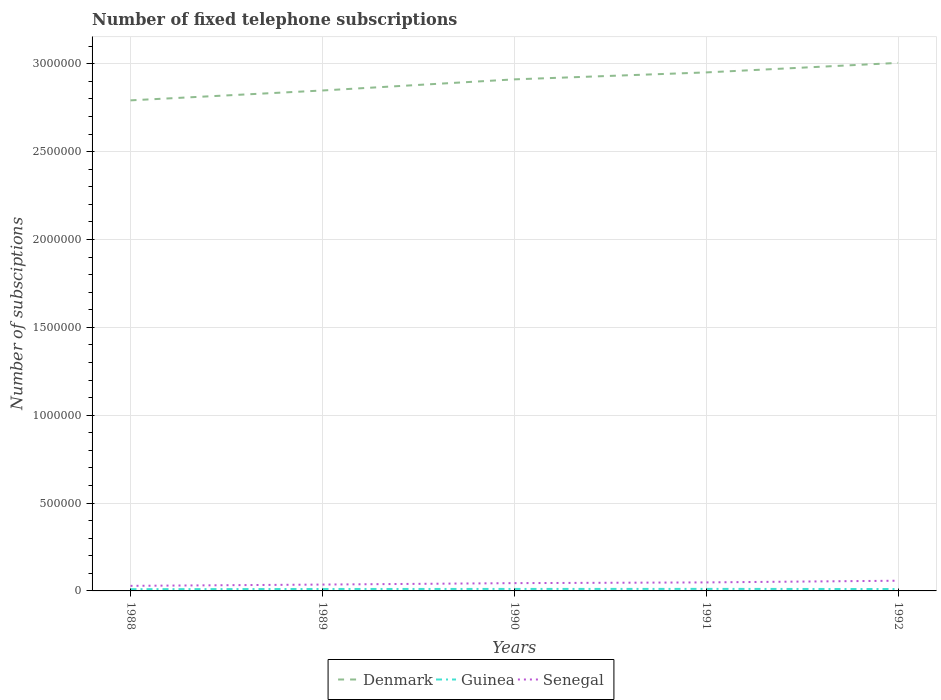What is the total number of fixed telephone subscriptions in Guinea in the graph?
Your answer should be compact. -788. What is the difference between the highest and the second highest number of fixed telephone subscriptions in Senegal?
Keep it short and to the point. 2.92e+04. What is the difference between the highest and the lowest number of fixed telephone subscriptions in Denmark?
Your response must be concise. 3. Is the number of fixed telephone subscriptions in Guinea strictly greater than the number of fixed telephone subscriptions in Senegal over the years?
Keep it short and to the point. Yes. How many years are there in the graph?
Keep it short and to the point. 5. What is the difference between two consecutive major ticks on the Y-axis?
Provide a succinct answer. 5.00e+05. Are the values on the major ticks of Y-axis written in scientific E-notation?
Keep it short and to the point. No. Does the graph contain any zero values?
Give a very brief answer. No. Does the graph contain grids?
Keep it short and to the point. Yes. Where does the legend appear in the graph?
Keep it short and to the point. Bottom center. How many legend labels are there?
Provide a succinct answer. 3. How are the legend labels stacked?
Your answer should be very brief. Horizontal. What is the title of the graph?
Ensure brevity in your answer.  Number of fixed telephone subscriptions. Does "Ghana" appear as one of the legend labels in the graph?
Provide a short and direct response. No. What is the label or title of the Y-axis?
Your response must be concise. Number of subsciptions. What is the Number of subsciptions in Denmark in 1988?
Provide a succinct answer. 2.79e+06. What is the Number of subsciptions in Guinea in 1988?
Your answer should be very brief. 10000. What is the Number of subsciptions in Senegal in 1988?
Ensure brevity in your answer.  2.89e+04. What is the Number of subsciptions of Denmark in 1989?
Your answer should be compact. 2.85e+06. What is the Number of subsciptions in Guinea in 1989?
Ensure brevity in your answer.  1.11e+04. What is the Number of subsciptions of Senegal in 1989?
Ensure brevity in your answer.  3.62e+04. What is the Number of subsciptions in Denmark in 1990?
Offer a terse response. 2.91e+06. What is the Number of subsciptions of Guinea in 1990?
Keep it short and to the point. 1.13e+04. What is the Number of subsciptions of Senegal in 1990?
Give a very brief answer. 4.43e+04. What is the Number of subsciptions in Denmark in 1991?
Keep it short and to the point. 2.95e+06. What is the Number of subsciptions of Guinea in 1991?
Ensure brevity in your answer.  1.16e+04. What is the Number of subsciptions in Senegal in 1991?
Your response must be concise. 4.85e+04. What is the Number of subsciptions in Denmark in 1992?
Offer a very short reply. 3.00e+06. What is the Number of subsciptions of Guinea in 1992?
Make the answer very short. 1.08e+04. What is the Number of subsciptions of Senegal in 1992?
Make the answer very short. 5.81e+04. Across all years, what is the maximum Number of subsciptions in Denmark?
Give a very brief answer. 3.00e+06. Across all years, what is the maximum Number of subsciptions in Guinea?
Make the answer very short. 1.16e+04. Across all years, what is the maximum Number of subsciptions of Senegal?
Offer a very short reply. 5.81e+04. Across all years, what is the minimum Number of subsciptions of Denmark?
Offer a terse response. 2.79e+06. Across all years, what is the minimum Number of subsciptions of Guinea?
Ensure brevity in your answer.  10000. Across all years, what is the minimum Number of subsciptions in Senegal?
Your answer should be very brief. 2.89e+04. What is the total Number of subsciptions of Denmark in the graph?
Offer a very short reply. 1.45e+07. What is the total Number of subsciptions in Guinea in the graph?
Ensure brevity in your answer.  5.47e+04. What is the total Number of subsciptions in Senegal in the graph?
Offer a terse response. 2.16e+05. What is the difference between the Number of subsciptions of Denmark in 1988 and that in 1989?
Make the answer very short. -5.61e+04. What is the difference between the Number of subsciptions in Guinea in 1988 and that in 1989?
Give a very brief answer. -1053. What is the difference between the Number of subsciptions in Senegal in 1988 and that in 1989?
Offer a very short reply. -7233. What is the difference between the Number of subsciptions of Denmark in 1988 and that in 1990?
Provide a short and direct response. -1.19e+05. What is the difference between the Number of subsciptions of Guinea in 1988 and that in 1990?
Your response must be concise. -1300. What is the difference between the Number of subsciptions of Senegal in 1988 and that in 1990?
Your answer should be very brief. -1.54e+04. What is the difference between the Number of subsciptions of Denmark in 1988 and that in 1991?
Provide a succinct answer. -1.59e+05. What is the difference between the Number of subsciptions of Guinea in 1988 and that in 1991?
Offer a very short reply. -1553. What is the difference between the Number of subsciptions of Senegal in 1988 and that in 1991?
Offer a very short reply. -1.95e+04. What is the difference between the Number of subsciptions of Denmark in 1988 and that in 1992?
Keep it short and to the point. -2.13e+05. What is the difference between the Number of subsciptions in Guinea in 1988 and that in 1992?
Your answer should be compact. -788. What is the difference between the Number of subsciptions in Senegal in 1988 and that in 1992?
Ensure brevity in your answer.  -2.92e+04. What is the difference between the Number of subsciptions in Denmark in 1989 and that in 1990?
Your answer should be compact. -6.33e+04. What is the difference between the Number of subsciptions of Guinea in 1989 and that in 1990?
Your answer should be compact. -247. What is the difference between the Number of subsciptions in Senegal in 1989 and that in 1990?
Offer a terse response. -8160. What is the difference between the Number of subsciptions in Denmark in 1989 and that in 1991?
Give a very brief answer. -1.03e+05. What is the difference between the Number of subsciptions in Guinea in 1989 and that in 1991?
Make the answer very short. -500. What is the difference between the Number of subsciptions of Senegal in 1989 and that in 1991?
Provide a short and direct response. -1.23e+04. What is the difference between the Number of subsciptions in Denmark in 1989 and that in 1992?
Your response must be concise. -1.57e+05. What is the difference between the Number of subsciptions of Guinea in 1989 and that in 1992?
Provide a short and direct response. 265. What is the difference between the Number of subsciptions of Senegal in 1989 and that in 1992?
Give a very brief answer. -2.19e+04. What is the difference between the Number of subsciptions in Denmark in 1990 and that in 1991?
Your response must be concise. -3.96e+04. What is the difference between the Number of subsciptions of Guinea in 1990 and that in 1991?
Ensure brevity in your answer.  -253. What is the difference between the Number of subsciptions of Senegal in 1990 and that in 1991?
Ensure brevity in your answer.  -4143. What is the difference between the Number of subsciptions in Denmark in 1990 and that in 1992?
Keep it short and to the point. -9.37e+04. What is the difference between the Number of subsciptions in Guinea in 1990 and that in 1992?
Give a very brief answer. 512. What is the difference between the Number of subsciptions of Senegal in 1990 and that in 1992?
Offer a terse response. -1.38e+04. What is the difference between the Number of subsciptions in Denmark in 1991 and that in 1992?
Ensure brevity in your answer.  -5.42e+04. What is the difference between the Number of subsciptions in Guinea in 1991 and that in 1992?
Keep it short and to the point. 765. What is the difference between the Number of subsciptions of Senegal in 1991 and that in 1992?
Provide a short and direct response. -9626. What is the difference between the Number of subsciptions of Denmark in 1988 and the Number of subsciptions of Guinea in 1989?
Provide a succinct answer. 2.78e+06. What is the difference between the Number of subsciptions of Denmark in 1988 and the Number of subsciptions of Senegal in 1989?
Provide a short and direct response. 2.76e+06. What is the difference between the Number of subsciptions in Guinea in 1988 and the Number of subsciptions in Senegal in 1989?
Provide a succinct answer. -2.62e+04. What is the difference between the Number of subsciptions in Denmark in 1988 and the Number of subsciptions in Guinea in 1990?
Offer a terse response. 2.78e+06. What is the difference between the Number of subsciptions in Denmark in 1988 and the Number of subsciptions in Senegal in 1990?
Your answer should be very brief. 2.75e+06. What is the difference between the Number of subsciptions of Guinea in 1988 and the Number of subsciptions of Senegal in 1990?
Keep it short and to the point. -3.43e+04. What is the difference between the Number of subsciptions of Denmark in 1988 and the Number of subsciptions of Guinea in 1991?
Your answer should be very brief. 2.78e+06. What is the difference between the Number of subsciptions of Denmark in 1988 and the Number of subsciptions of Senegal in 1991?
Ensure brevity in your answer.  2.74e+06. What is the difference between the Number of subsciptions of Guinea in 1988 and the Number of subsciptions of Senegal in 1991?
Make the answer very short. -3.85e+04. What is the difference between the Number of subsciptions of Denmark in 1988 and the Number of subsciptions of Guinea in 1992?
Give a very brief answer. 2.78e+06. What is the difference between the Number of subsciptions of Denmark in 1988 and the Number of subsciptions of Senegal in 1992?
Provide a short and direct response. 2.73e+06. What is the difference between the Number of subsciptions of Guinea in 1988 and the Number of subsciptions of Senegal in 1992?
Make the answer very short. -4.81e+04. What is the difference between the Number of subsciptions of Denmark in 1989 and the Number of subsciptions of Guinea in 1990?
Make the answer very short. 2.84e+06. What is the difference between the Number of subsciptions in Denmark in 1989 and the Number of subsciptions in Senegal in 1990?
Keep it short and to the point. 2.80e+06. What is the difference between the Number of subsciptions in Guinea in 1989 and the Number of subsciptions in Senegal in 1990?
Keep it short and to the point. -3.33e+04. What is the difference between the Number of subsciptions of Denmark in 1989 and the Number of subsciptions of Guinea in 1991?
Your answer should be very brief. 2.84e+06. What is the difference between the Number of subsciptions in Denmark in 1989 and the Number of subsciptions in Senegal in 1991?
Your answer should be compact. 2.80e+06. What is the difference between the Number of subsciptions in Guinea in 1989 and the Number of subsciptions in Senegal in 1991?
Give a very brief answer. -3.74e+04. What is the difference between the Number of subsciptions in Denmark in 1989 and the Number of subsciptions in Guinea in 1992?
Make the answer very short. 2.84e+06. What is the difference between the Number of subsciptions of Denmark in 1989 and the Number of subsciptions of Senegal in 1992?
Give a very brief answer. 2.79e+06. What is the difference between the Number of subsciptions in Guinea in 1989 and the Number of subsciptions in Senegal in 1992?
Offer a very short reply. -4.70e+04. What is the difference between the Number of subsciptions of Denmark in 1990 and the Number of subsciptions of Guinea in 1991?
Offer a very short reply. 2.90e+06. What is the difference between the Number of subsciptions in Denmark in 1990 and the Number of subsciptions in Senegal in 1991?
Offer a terse response. 2.86e+06. What is the difference between the Number of subsciptions in Guinea in 1990 and the Number of subsciptions in Senegal in 1991?
Provide a short and direct response. -3.72e+04. What is the difference between the Number of subsciptions in Denmark in 1990 and the Number of subsciptions in Guinea in 1992?
Give a very brief answer. 2.90e+06. What is the difference between the Number of subsciptions in Denmark in 1990 and the Number of subsciptions in Senegal in 1992?
Keep it short and to the point. 2.85e+06. What is the difference between the Number of subsciptions of Guinea in 1990 and the Number of subsciptions of Senegal in 1992?
Make the answer very short. -4.68e+04. What is the difference between the Number of subsciptions of Denmark in 1991 and the Number of subsciptions of Guinea in 1992?
Your answer should be compact. 2.94e+06. What is the difference between the Number of subsciptions of Denmark in 1991 and the Number of subsciptions of Senegal in 1992?
Make the answer very short. 2.89e+06. What is the difference between the Number of subsciptions in Guinea in 1991 and the Number of subsciptions in Senegal in 1992?
Give a very brief answer. -4.65e+04. What is the average Number of subsciptions of Denmark per year?
Keep it short and to the point. 2.90e+06. What is the average Number of subsciptions of Guinea per year?
Provide a succinct answer. 1.09e+04. What is the average Number of subsciptions in Senegal per year?
Your answer should be very brief. 4.32e+04. In the year 1988, what is the difference between the Number of subsciptions of Denmark and Number of subsciptions of Guinea?
Keep it short and to the point. 2.78e+06. In the year 1988, what is the difference between the Number of subsciptions of Denmark and Number of subsciptions of Senegal?
Offer a very short reply. 2.76e+06. In the year 1988, what is the difference between the Number of subsciptions of Guinea and Number of subsciptions of Senegal?
Provide a succinct answer. -1.89e+04. In the year 1989, what is the difference between the Number of subsciptions of Denmark and Number of subsciptions of Guinea?
Offer a very short reply. 2.84e+06. In the year 1989, what is the difference between the Number of subsciptions of Denmark and Number of subsciptions of Senegal?
Make the answer very short. 2.81e+06. In the year 1989, what is the difference between the Number of subsciptions in Guinea and Number of subsciptions in Senegal?
Offer a very short reply. -2.51e+04. In the year 1990, what is the difference between the Number of subsciptions in Denmark and Number of subsciptions in Guinea?
Offer a very short reply. 2.90e+06. In the year 1990, what is the difference between the Number of subsciptions in Denmark and Number of subsciptions in Senegal?
Provide a succinct answer. 2.87e+06. In the year 1990, what is the difference between the Number of subsciptions in Guinea and Number of subsciptions in Senegal?
Your response must be concise. -3.30e+04. In the year 1991, what is the difference between the Number of subsciptions of Denmark and Number of subsciptions of Guinea?
Ensure brevity in your answer.  2.94e+06. In the year 1991, what is the difference between the Number of subsciptions of Denmark and Number of subsciptions of Senegal?
Your answer should be very brief. 2.90e+06. In the year 1991, what is the difference between the Number of subsciptions of Guinea and Number of subsciptions of Senegal?
Ensure brevity in your answer.  -3.69e+04. In the year 1992, what is the difference between the Number of subsciptions in Denmark and Number of subsciptions in Guinea?
Make the answer very short. 2.99e+06. In the year 1992, what is the difference between the Number of subsciptions of Denmark and Number of subsciptions of Senegal?
Your answer should be very brief. 2.95e+06. In the year 1992, what is the difference between the Number of subsciptions of Guinea and Number of subsciptions of Senegal?
Ensure brevity in your answer.  -4.73e+04. What is the ratio of the Number of subsciptions of Denmark in 1988 to that in 1989?
Ensure brevity in your answer.  0.98. What is the ratio of the Number of subsciptions of Guinea in 1988 to that in 1989?
Keep it short and to the point. 0.9. What is the ratio of the Number of subsciptions in Senegal in 1988 to that in 1989?
Provide a succinct answer. 0.8. What is the ratio of the Number of subsciptions in Guinea in 1988 to that in 1990?
Ensure brevity in your answer.  0.89. What is the ratio of the Number of subsciptions of Senegal in 1988 to that in 1990?
Make the answer very short. 0.65. What is the ratio of the Number of subsciptions of Denmark in 1988 to that in 1991?
Offer a terse response. 0.95. What is the ratio of the Number of subsciptions of Guinea in 1988 to that in 1991?
Offer a very short reply. 0.87. What is the ratio of the Number of subsciptions in Senegal in 1988 to that in 1991?
Make the answer very short. 0.6. What is the ratio of the Number of subsciptions in Denmark in 1988 to that in 1992?
Your response must be concise. 0.93. What is the ratio of the Number of subsciptions in Guinea in 1988 to that in 1992?
Offer a terse response. 0.93. What is the ratio of the Number of subsciptions in Senegal in 1988 to that in 1992?
Provide a short and direct response. 0.5. What is the ratio of the Number of subsciptions in Denmark in 1989 to that in 1990?
Provide a succinct answer. 0.98. What is the ratio of the Number of subsciptions of Guinea in 1989 to that in 1990?
Provide a short and direct response. 0.98. What is the ratio of the Number of subsciptions in Senegal in 1989 to that in 1990?
Your response must be concise. 0.82. What is the ratio of the Number of subsciptions of Denmark in 1989 to that in 1991?
Make the answer very short. 0.97. What is the ratio of the Number of subsciptions in Guinea in 1989 to that in 1991?
Offer a very short reply. 0.96. What is the ratio of the Number of subsciptions in Senegal in 1989 to that in 1991?
Your response must be concise. 0.75. What is the ratio of the Number of subsciptions of Denmark in 1989 to that in 1992?
Your response must be concise. 0.95. What is the ratio of the Number of subsciptions of Guinea in 1989 to that in 1992?
Offer a terse response. 1.02. What is the ratio of the Number of subsciptions of Senegal in 1989 to that in 1992?
Provide a succinct answer. 0.62. What is the ratio of the Number of subsciptions in Denmark in 1990 to that in 1991?
Make the answer very short. 0.99. What is the ratio of the Number of subsciptions of Guinea in 1990 to that in 1991?
Give a very brief answer. 0.98. What is the ratio of the Number of subsciptions in Senegal in 1990 to that in 1991?
Provide a short and direct response. 0.91. What is the ratio of the Number of subsciptions in Denmark in 1990 to that in 1992?
Ensure brevity in your answer.  0.97. What is the ratio of the Number of subsciptions of Guinea in 1990 to that in 1992?
Your answer should be compact. 1.05. What is the ratio of the Number of subsciptions of Senegal in 1990 to that in 1992?
Make the answer very short. 0.76. What is the ratio of the Number of subsciptions in Denmark in 1991 to that in 1992?
Your answer should be compact. 0.98. What is the ratio of the Number of subsciptions of Guinea in 1991 to that in 1992?
Your response must be concise. 1.07. What is the ratio of the Number of subsciptions in Senegal in 1991 to that in 1992?
Offer a terse response. 0.83. What is the difference between the highest and the second highest Number of subsciptions of Denmark?
Keep it short and to the point. 5.42e+04. What is the difference between the highest and the second highest Number of subsciptions in Guinea?
Ensure brevity in your answer.  253. What is the difference between the highest and the second highest Number of subsciptions of Senegal?
Your answer should be compact. 9626. What is the difference between the highest and the lowest Number of subsciptions of Denmark?
Offer a terse response. 2.13e+05. What is the difference between the highest and the lowest Number of subsciptions of Guinea?
Keep it short and to the point. 1553. What is the difference between the highest and the lowest Number of subsciptions of Senegal?
Your response must be concise. 2.92e+04. 